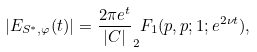Convert formula to latex. <formula><loc_0><loc_0><loc_500><loc_500>| E _ { S ^ { * } , \varphi } ( t ) | = \frac { 2 \pi e ^ { t } } { | C | } _ { 2 } F _ { 1 } ( p , p ; 1 ; e ^ { 2 \nu t } ) ,</formula> 